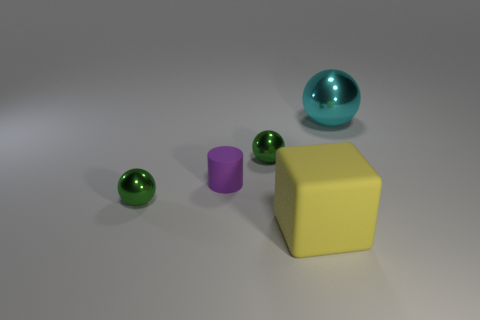Add 3 small things. How many objects exist? 8 Subtract all cubes. How many objects are left? 4 Subtract 0 blue cylinders. How many objects are left? 5 Subtract all yellow objects. Subtract all green metal objects. How many objects are left? 2 Add 5 big metallic spheres. How many big metallic spheres are left? 6 Add 2 yellow rubber objects. How many yellow rubber objects exist? 3 